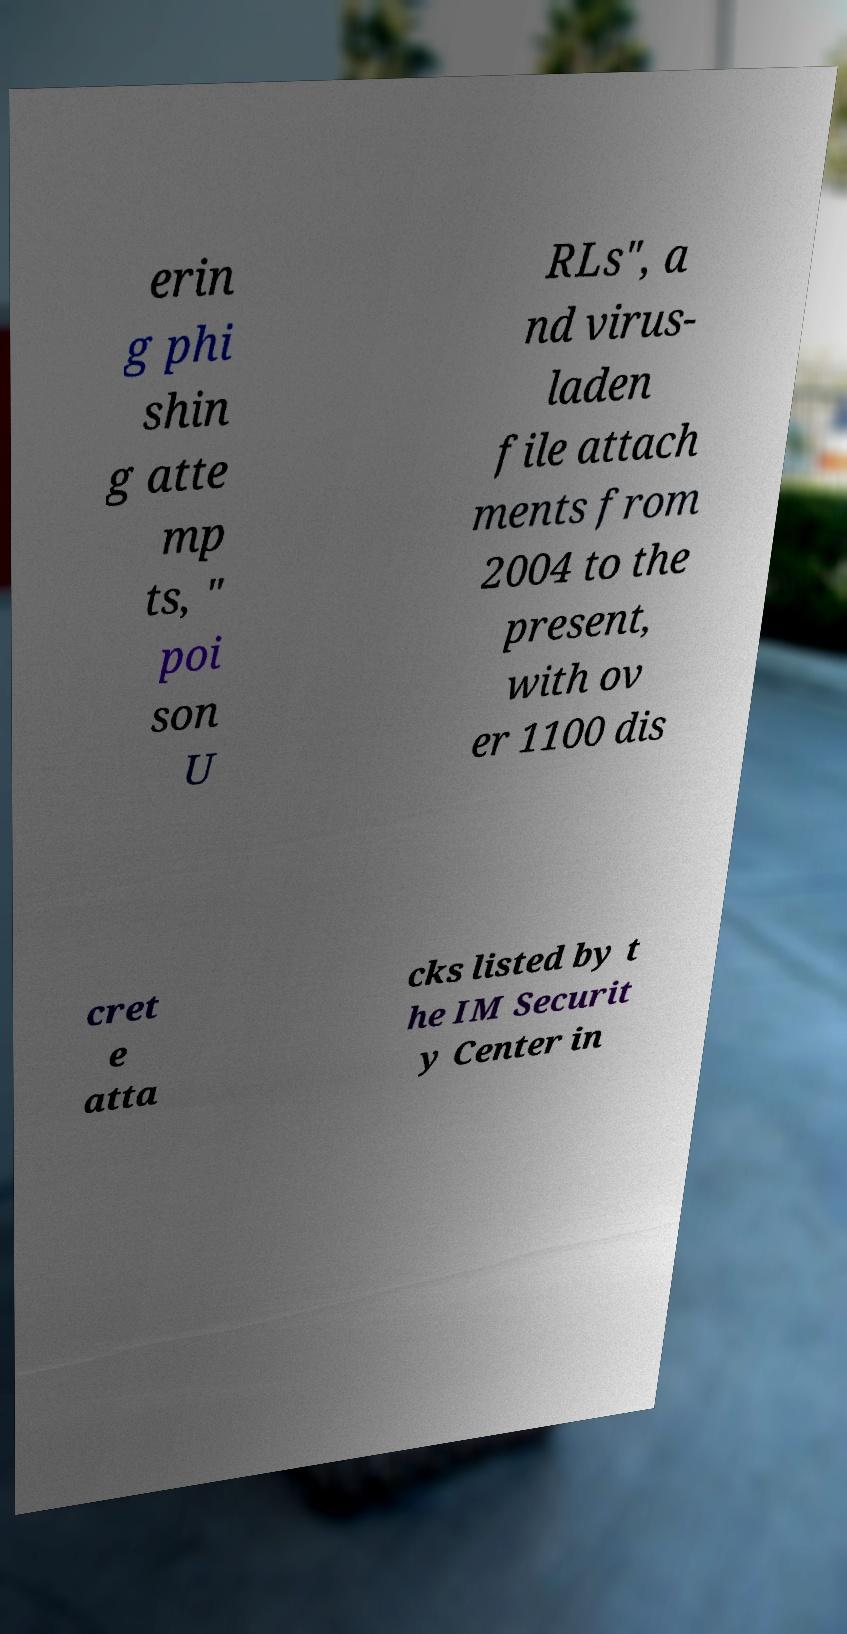Could you extract and type out the text from this image? erin g phi shin g atte mp ts, " poi son U RLs", a nd virus- laden file attach ments from 2004 to the present, with ov er 1100 dis cret e atta cks listed by t he IM Securit y Center in 